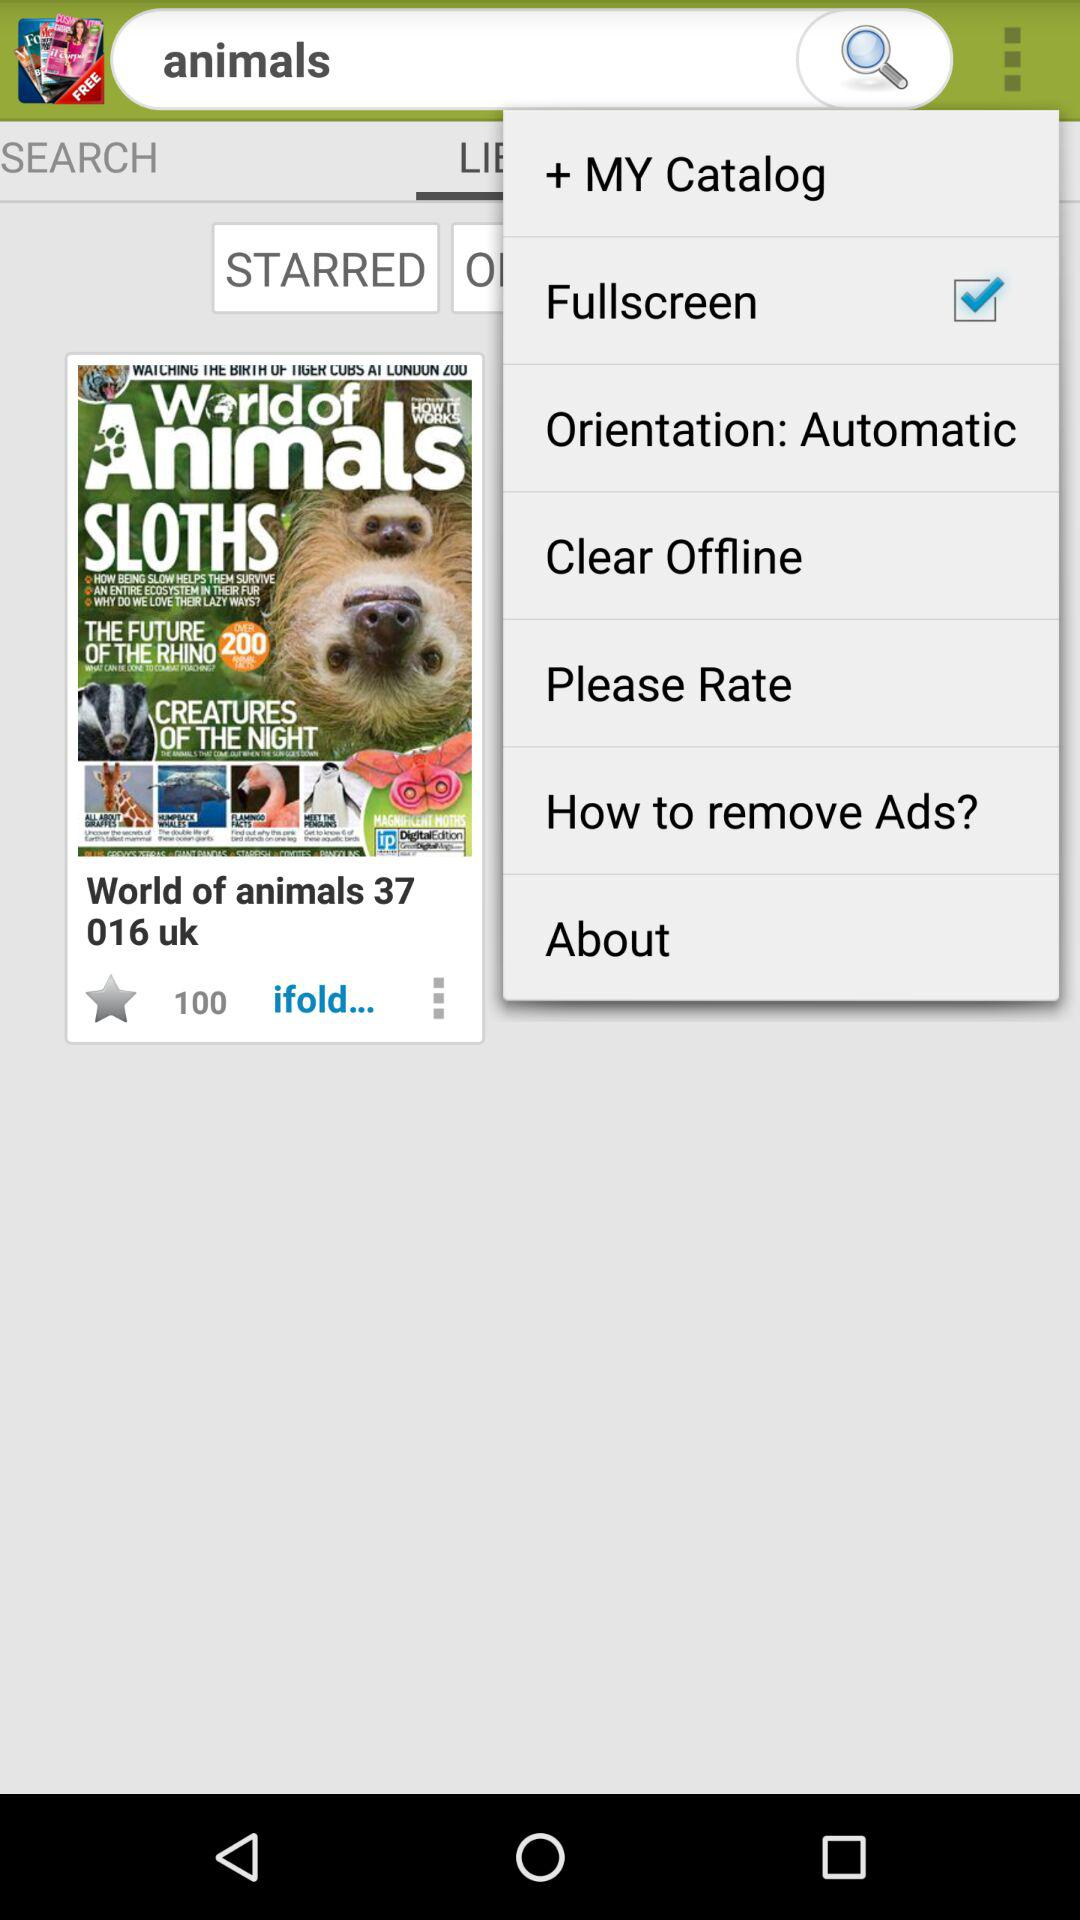What is the status of "Fullscreen"? The status is "on". 